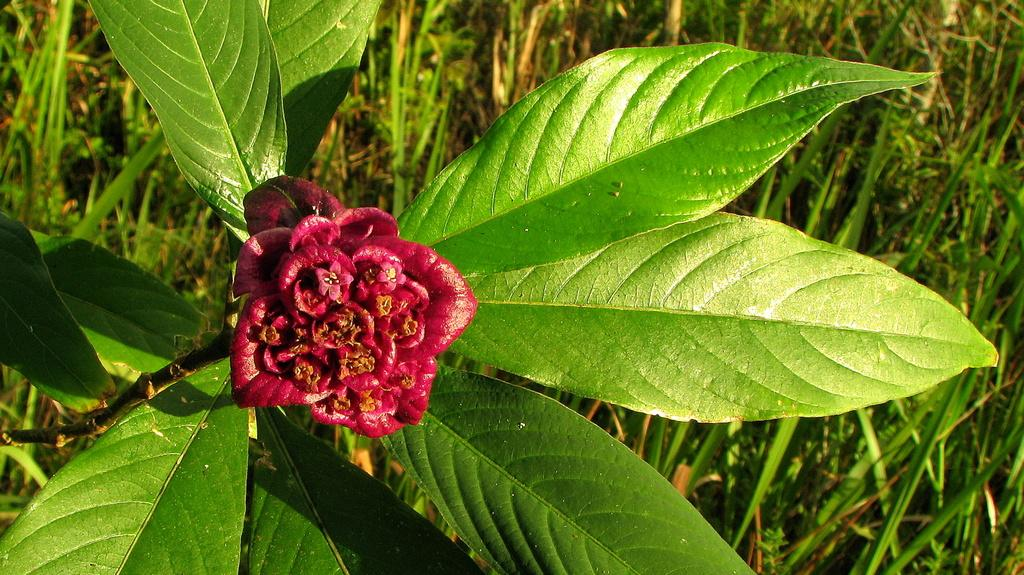What type of flower can be seen in the image? There is a red color flower in the image. Is the flower part of a larger plant? Yes, the flower is attached to a plant. What other parts of the plant are visible in the image? There are leaves in the image. What is the background of the image? There is grass in the backdrop of the image. What advice does the father give about death in the image? There is no father or mention of death in the image; it features a red color flower, a plant, leaves, and grass. 